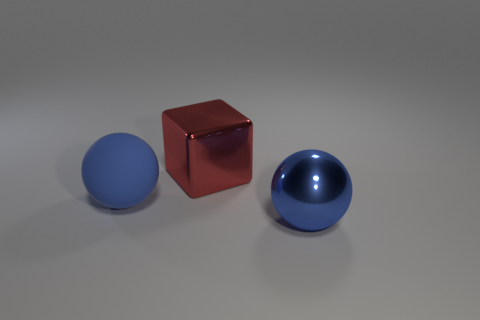There is a large thing behind the blue rubber object; is there a ball that is behind it?
Provide a short and direct response. No. There is a large red metal thing; what shape is it?
Ensure brevity in your answer.  Cube. What size is the object that is the same color as the rubber ball?
Offer a terse response. Large. There is a blue sphere on the left side of the large ball on the right side of the shiny cube; what size is it?
Offer a very short reply. Large. There is a blue object behind the big shiny sphere; what is its size?
Keep it short and to the point. Large. Are there fewer blue objects that are right of the rubber sphere than red cubes behind the big cube?
Your response must be concise. No. The matte object has what color?
Provide a succinct answer. Blue. Is there a metal block of the same color as the metallic ball?
Provide a short and direct response. No. There is a blue thing in front of the blue sphere that is on the left side of the big shiny thing behind the big blue metal thing; what is its shape?
Give a very brief answer. Sphere. There is a blue ball on the right side of the big blue rubber ball; what is its material?
Offer a very short reply. Metal. 